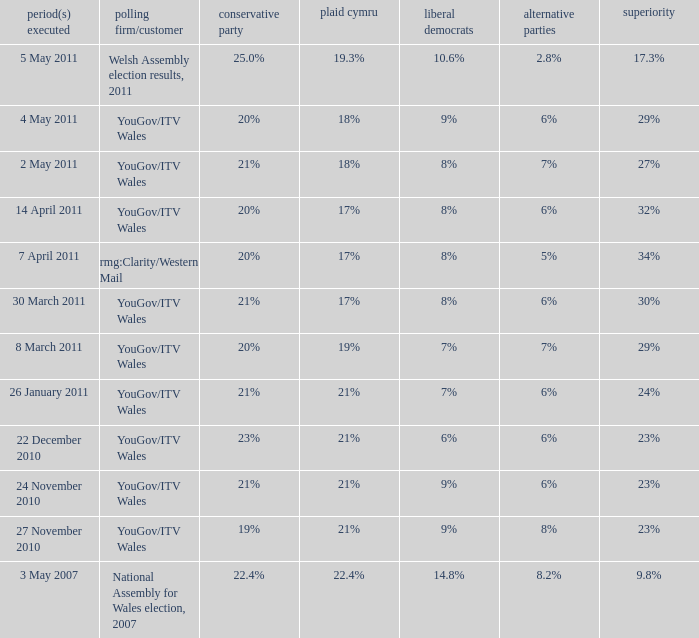What is the cons for lib dem of 8% and a lead of 27% 21%. 